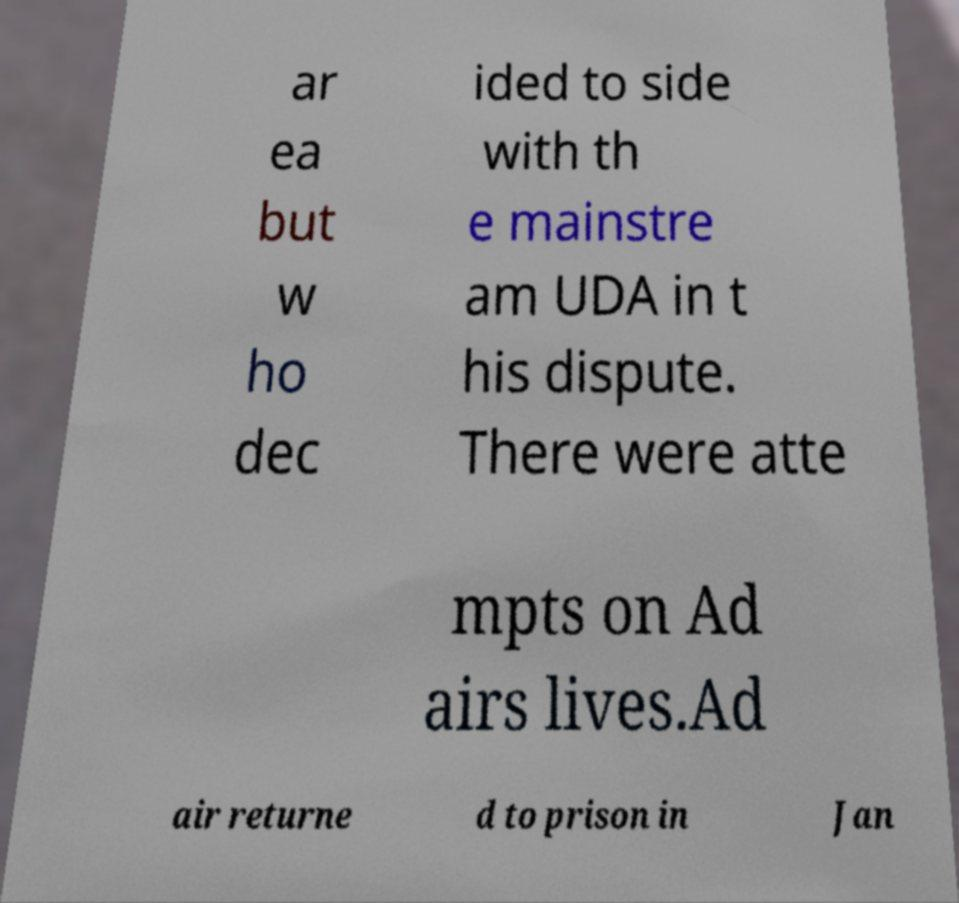There's text embedded in this image that I need extracted. Can you transcribe it verbatim? ar ea but w ho dec ided to side with th e mainstre am UDA in t his dispute. There were atte mpts on Ad airs lives.Ad air returne d to prison in Jan 